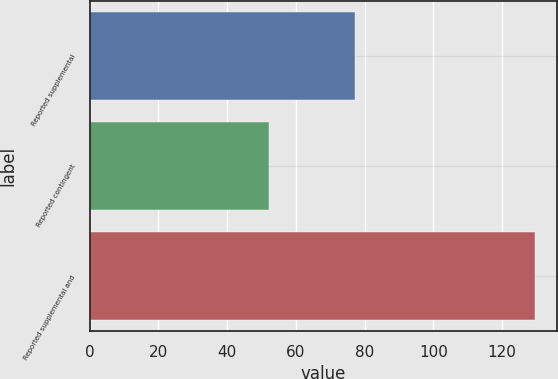<chart> <loc_0><loc_0><loc_500><loc_500><bar_chart><fcel>Reported supplemental<fcel>Reported contingent<fcel>Reported supplemental and<nl><fcel>77.3<fcel>52.1<fcel>129.4<nl></chart> 